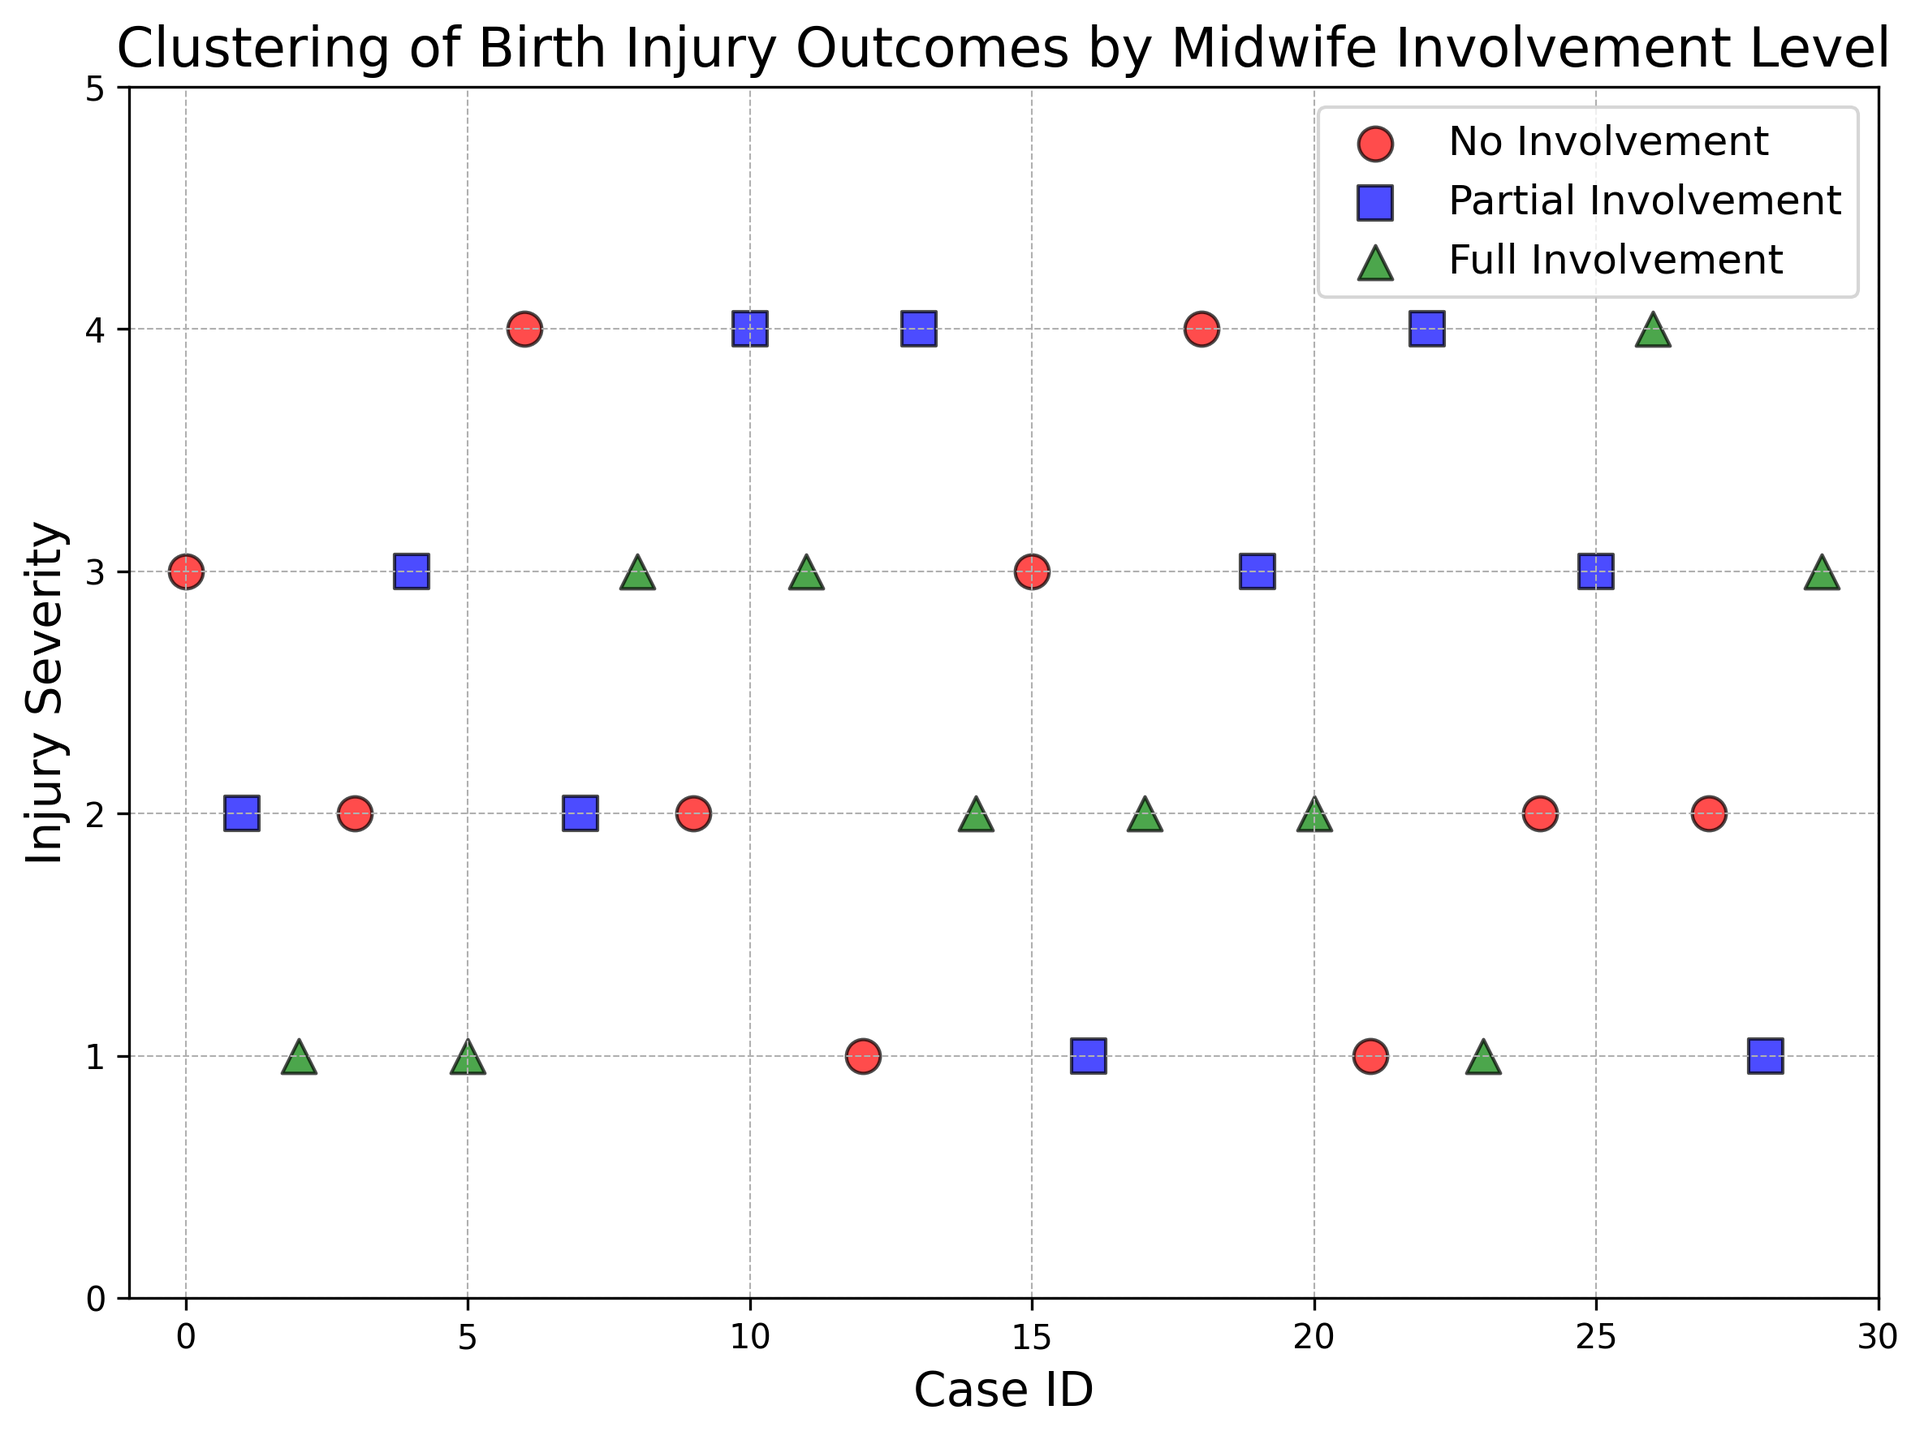What's the highest injury severity level observed with no midwife involvement? The figure shows the injury severity on the y-axis and involvement levels are color-coded. The highest point among the red markers indicates the highest severity for no involvement cases.
Answer: 4 Which involvement level shows the most varied severity levels? In the figure, blue, red, and green markers represent partial, no, and full involvement levels respectively. Partial involvement has severity levels ranging from 1 to 4, showing the most variation.
Answer: Partial involvement How many cases did full midwife involvement result in an injury severity of 3? By observing the green markers on the y-axis at level 3, count the occurrences. There are two such cases.
Answer: 2 Which involvement level has the least average injury severity? By visually estimating the spread and average position of the markers on the y-axis for each color, the green markers (full involvement) appear to cluster lower around severity levels 1 and 2.
Answer: Full involvement Do more cases with no midwife involvement show higher injury severities compared to full involvement? Observe the positions of the red markers relative to the green markers on the y-axis. Red markers are seen more frequently at higher severity levels.
Answer: Yes What's the average injury severity for cases with partial involvement? Observe the spread of blue markers and calculate the mean. Blue markers (partial involvement) show levels 1, 2, 3, and 4. Sum is 1 + 2 + 3 + 4 + 1 + 4 + 3 = 18 across 7 instances, so 18 / 7 is approximately 2.57.
Answer: 2.57 Among cases with injury severity of 2, which involvement level is most common? Check the y-axis at severity level 2 and count the markers for each color. There are more red markers at severity level 2.
Answer: No involvement Is there any involvement level that does not result in injury severity 4? We see that green markers are absent at severity level 4, indicating no full involvement cases resulted in severity 4.
Answer: Full involvement Compare the highest injury severities for partial vs. full involvement. Which is higher? Check the uppermost position of the blue markers (partial) and green markers (full). Blue markers reach level 4, while green do not.
Answer: Partial involvement How many total cases resulted in the lowest injury severity? Count markers at the 1 level on the y-axis. There are 6 such markers, regardless of color.
Answer: 6 